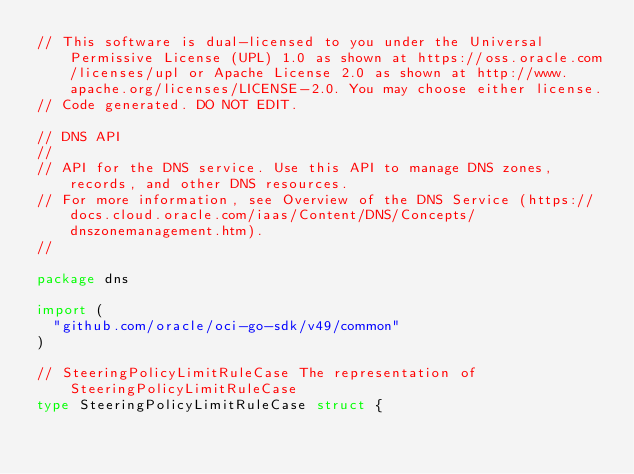Convert code to text. <code><loc_0><loc_0><loc_500><loc_500><_Go_>// This software is dual-licensed to you under the Universal Permissive License (UPL) 1.0 as shown at https://oss.oracle.com/licenses/upl or Apache License 2.0 as shown at http://www.apache.org/licenses/LICENSE-2.0. You may choose either license.
// Code generated. DO NOT EDIT.

// DNS API
//
// API for the DNS service. Use this API to manage DNS zones, records, and other DNS resources.
// For more information, see Overview of the DNS Service (https://docs.cloud.oracle.com/iaas/Content/DNS/Concepts/dnszonemanagement.htm).
//

package dns

import (
	"github.com/oracle/oci-go-sdk/v49/common"
)

// SteeringPolicyLimitRuleCase The representation of SteeringPolicyLimitRuleCase
type SteeringPolicyLimitRuleCase struct {
</code> 